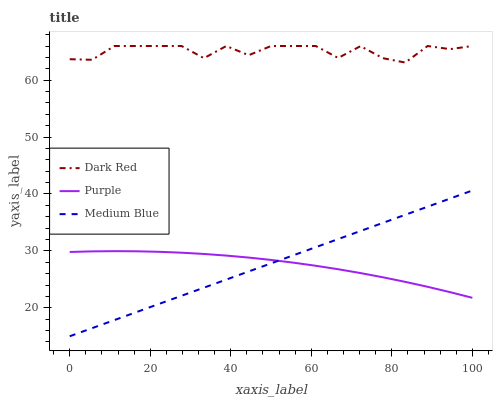Does Purple have the minimum area under the curve?
Answer yes or no. Yes. Does Dark Red have the maximum area under the curve?
Answer yes or no. Yes. Does Medium Blue have the minimum area under the curve?
Answer yes or no. No. Does Medium Blue have the maximum area under the curve?
Answer yes or no. No. Is Medium Blue the smoothest?
Answer yes or no. Yes. Is Dark Red the roughest?
Answer yes or no. Yes. Is Dark Red the smoothest?
Answer yes or no. No. Is Medium Blue the roughest?
Answer yes or no. No. Does Medium Blue have the lowest value?
Answer yes or no. Yes. Does Dark Red have the lowest value?
Answer yes or no. No. Does Dark Red have the highest value?
Answer yes or no. Yes. Does Medium Blue have the highest value?
Answer yes or no. No. Is Purple less than Dark Red?
Answer yes or no. Yes. Is Dark Red greater than Medium Blue?
Answer yes or no. Yes. Does Medium Blue intersect Purple?
Answer yes or no. Yes. Is Medium Blue less than Purple?
Answer yes or no. No. Is Medium Blue greater than Purple?
Answer yes or no. No. Does Purple intersect Dark Red?
Answer yes or no. No. 